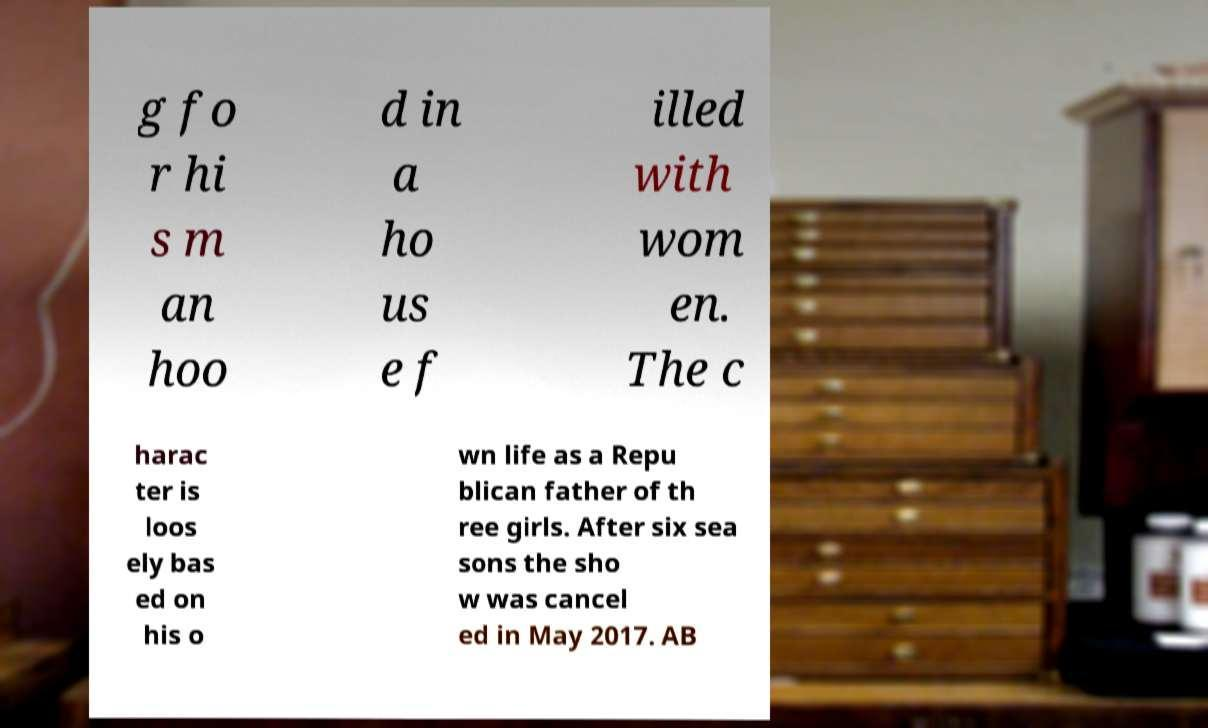Can you read and provide the text displayed in the image?This photo seems to have some interesting text. Can you extract and type it out for me? g fo r hi s m an hoo d in a ho us e f illed with wom en. The c harac ter is loos ely bas ed on his o wn life as a Repu blican father of th ree girls. After six sea sons the sho w was cancel ed in May 2017. AB 